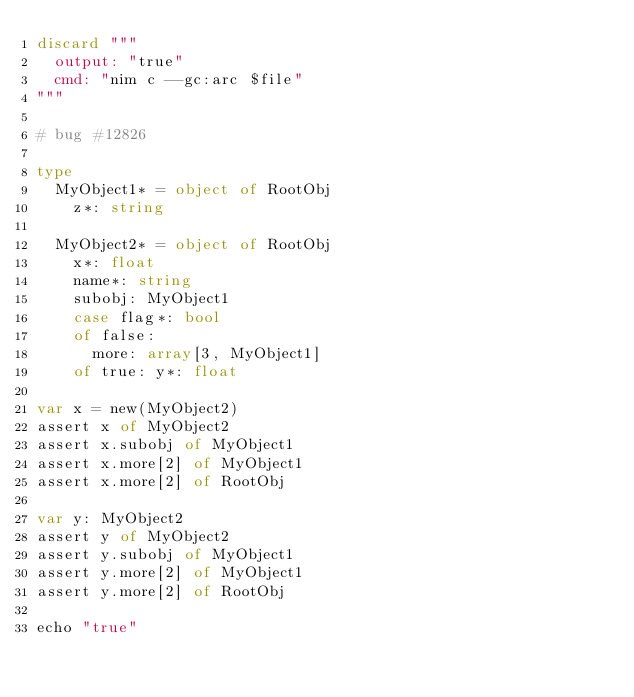<code> <loc_0><loc_0><loc_500><loc_500><_Nim_>discard """
  output: "true"
  cmd: "nim c --gc:arc $file"
"""

# bug #12826

type
  MyObject1* = object of RootObj
    z*: string

  MyObject2* = object of RootObj
    x*: float
    name*: string
    subobj: MyObject1
    case flag*: bool
    of false:
      more: array[3, MyObject1]
    of true: y*: float

var x = new(MyObject2)
assert x of MyObject2
assert x.subobj of MyObject1
assert x.more[2] of MyObject1
assert x.more[2] of RootObj

var y: MyObject2
assert y of MyObject2
assert y.subobj of MyObject1
assert y.more[2] of MyObject1
assert y.more[2] of RootObj

echo "true"
</code> 